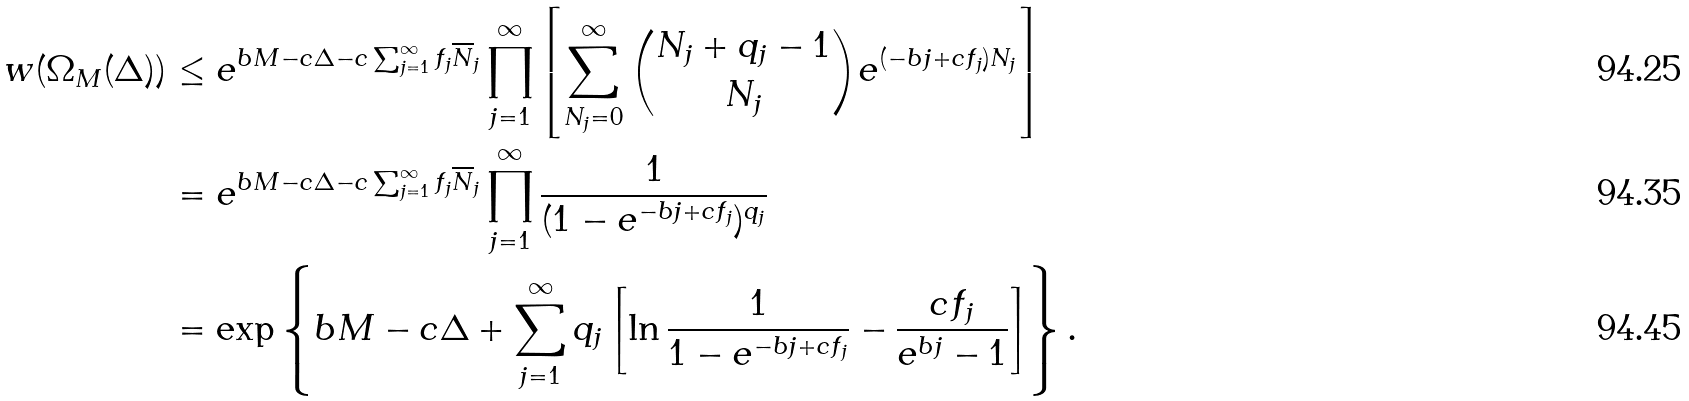Convert formula to latex. <formula><loc_0><loc_0><loc_500><loc_500>w ( \Omega _ { M } ( \Delta ) ) & \leq e ^ { b M - c \Delta - c \sum _ { j = 1 } ^ { \infty } f _ { j } \overline { N } _ { j } } \prod _ { j = 1 } ^ { \infty } \left [ \sum _ { N _ { j } = 0 } ^ { \infty } \binom { N _ { j } + q _ { j } - 1 } { N _ { j } } e ^ { ( - b j + c f _ { j } ) N _ { j } } \right ] \\ & = e ^ { b M - c \Delta - c \sum _ { j = 1 } ^ { \infty } f _ { j } \overline { N } _ { j } } \prod _ { j = 1 } ^ { \infty } \frac { 1 } { ( 1 - e ^ { - b j + c f _ { j } } ) ^ { q _ { j } } } \\ & = \exp \left \{ b M - c \Delta + \sum _ { j = 1 } ^ { \infty } q _ { j } \left [ \ln \frac { 1 } { 1 - e ^ { - b j + c f _ { j } } } - \frac { c f _ { j } } { e ^ { b j } - 1 } \right ] \right \} .</formula> 